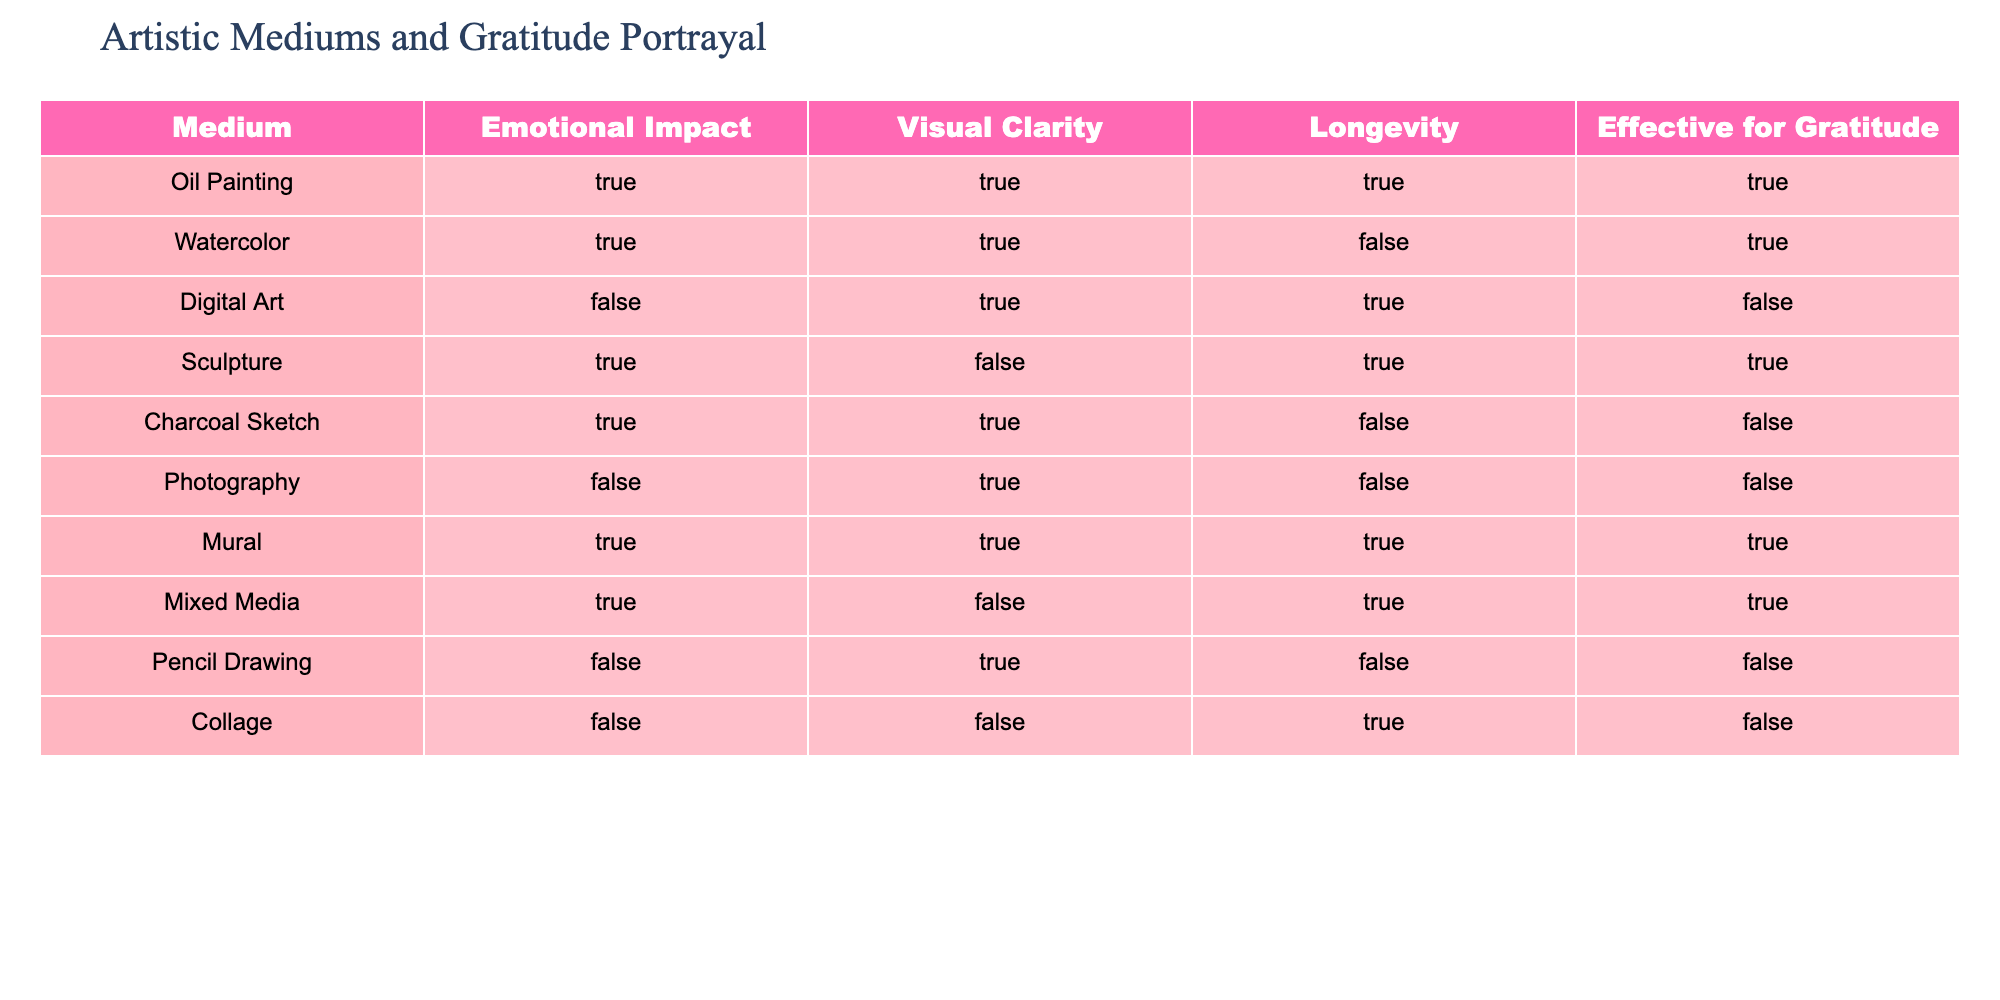What artistic medium has the highest emotional impact while also being effective for portraying gratitude? Upon reviewing the table, I see that both Oil Painting and Sculpture have True under Emotional Impact and Effective for Gratitude. However, Oil Painting is the only one that also indicates True for Visual Clarity and Longevity, making it the top choice when considering all factors.
Answer: Oil Painting Which medium is effective for gratitude but has a false rating for longevity? By examining the table, Watercolor and Mixed Media have True for Effective for Gratitude, but Mixed Media has True for Longevity, while Watercolor has False. Therefore, Watercolor is the correct answer.
Answer: Watercolor How many mediums have Visual Clarity rated as True and are Effective for Gratitude? To find this, I can filter the table for mediums with True in both Visual Clarity and Effective for Gratitude. These are Oil Painting, Watercolor, Sculpture, Mural, and Mixed Media. This results in a total of five mediums.
Answer: 5 Is Digital Art effective for portraying gratitude? I can check directly in the table under Effective for Gratitude for Digital Art, which shows False. This indicates that it is not effective for portraying gratitude.
Answer: No What is the total number of mediums that have both Emotional Impact and Effective for Gratitude rated as True? By scanning through the table, I can identify the mediums: Oil Painting, Watercolor, Sculpture, and Mural, which adds up to four mediums that satisfy both conditions.
Answer: 4 Which medium offers the highest combination of Emotional Impact, Visual Clarity, and Effective for Gratitude? Looking at the table, Oil Painting is the only medium that has both Emotional Impact, Visual Clarity, and Effective for Gratitude all rated as True. Therefore, it stands out as offering the highest combination.
Answer: Oil Painting Does Collage have Emotional Impact rated as True or False? I will check the table specifically for Collage's rating under Emotional Impact, which is clearly marked as False.
Answer: False How many mediums are ineffective for gratitude and also have Visual Clarity rated as False? Analyzing the table, I find that Collage and Sculpture have Visual Clarity marked as False. Both mediums show as ineffective for gratitude. Therefore, there are two mediums fitting this criteria.
Answer: 2 